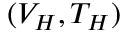<formula> <loc_0><loc_0><loc_500><loc_500>( V _ { H } , T _ { H } )</formula> 